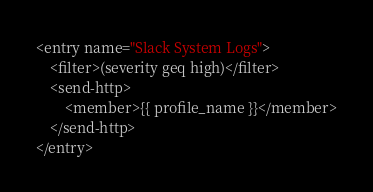Convert code to text. <code><loc_0><loc_0><loc_500><loc_500><_XML_><entry name="Slack System Logs">
    <filter>(severity geq high)</filter>
    <send-http>
        <member>{{ profile_name }}</member>
    </send-http>
</entry></code> 